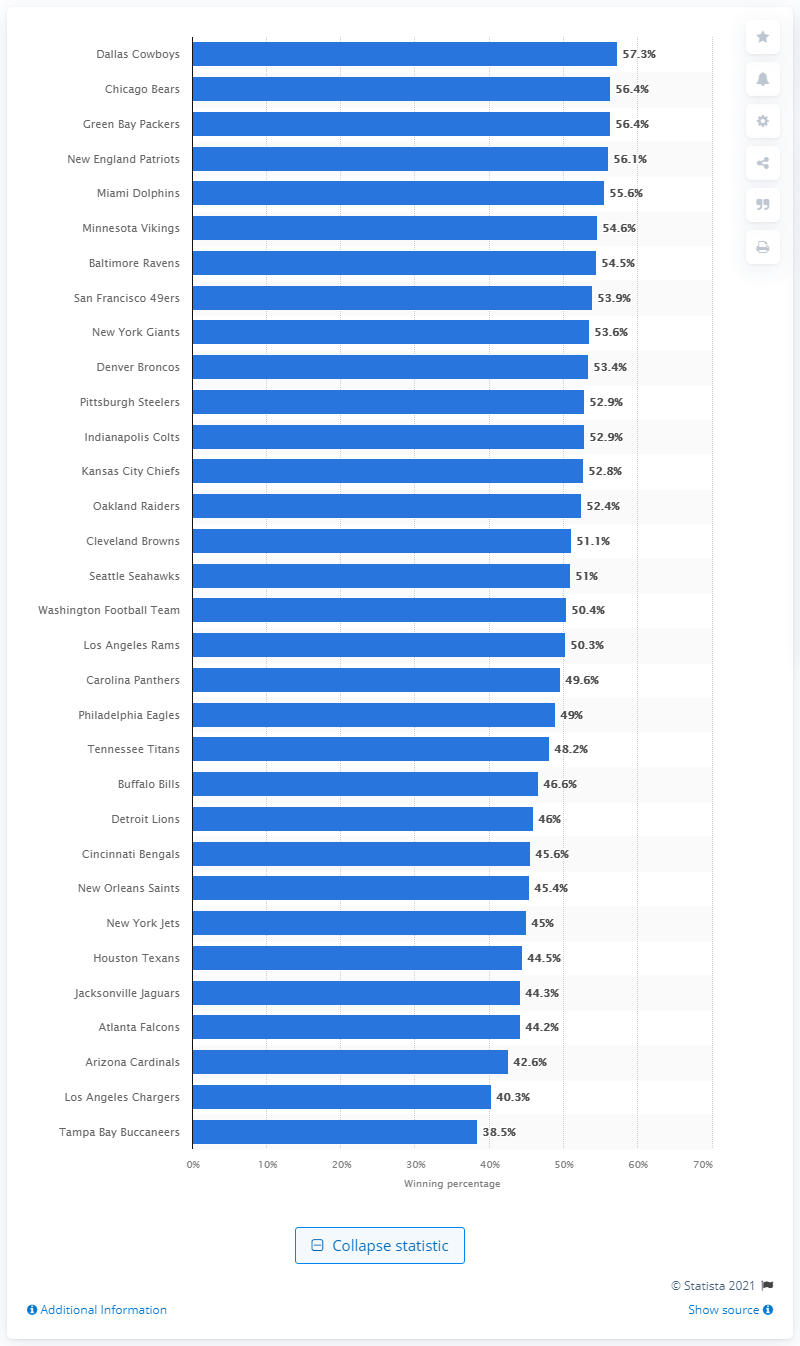Point out several critical features in this image. The Tampa Bay Buccaneers' regular season win percentage is 38.5%. Having won 57.3% of their games, the Dallas Cowboys are a dominant force in the National Football League. As per the data available, the Dallas Cowboys have maintained the highest winning percentage during the regular season of the National Football League. 